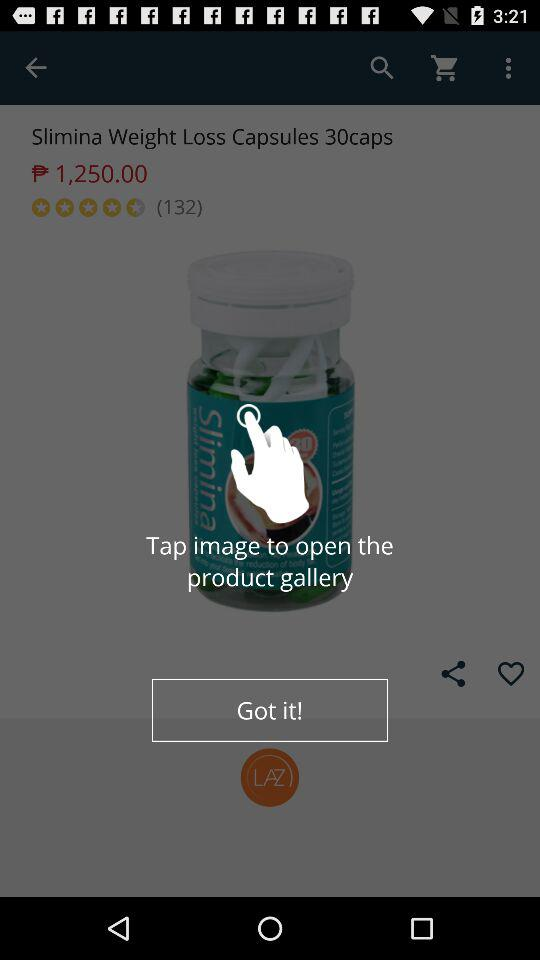How much is the product?
Answer the question using a single word or phrase. $1,250.00 